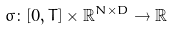Convert formula to latex. <formula><loc_0><loc_0><loc_500><loc_500>\sigma \colon [ 0 , T ] \times \mathbb { R } ^ { N \times D } \rightarrow \mathbb { R }</formula> 